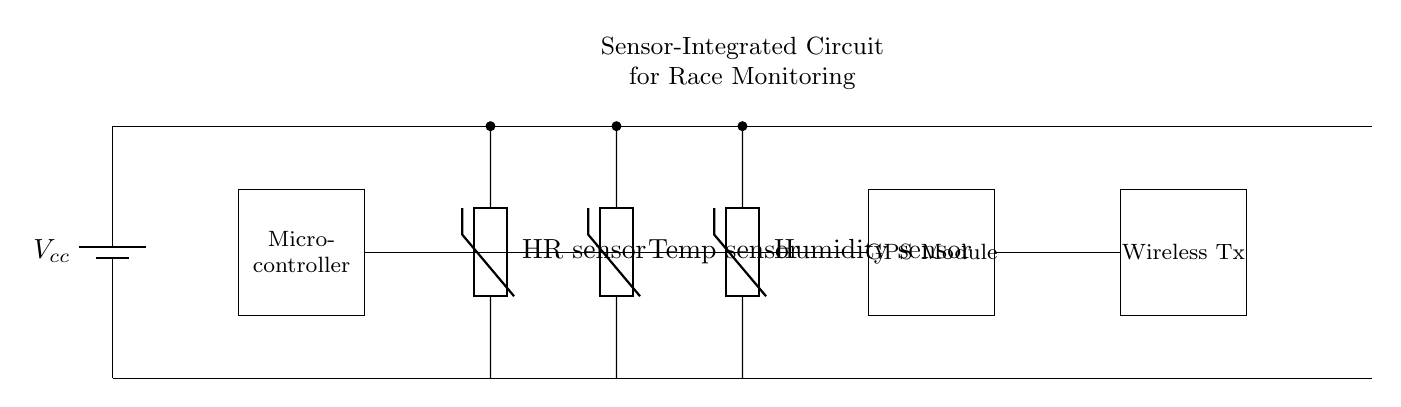What is the main power source in the circuit? The power source is a battery that provides voltage to the circuit. It is shown in the circuit as a battery symbol marked Vcc.
Answer: Battery How many sensors are in the circuit? The circuit contains three sensors: a heart rate sensor, a temperature sensor, and a humidity sensor. Each sensor is represented by a thermistor symbol.
Answer: Three What does the microcontroller connect to? The microcontroller connects to the heart rate sensor, temperature sensor, humidity sensor, and the GPS module. These connections allow it to gather data from these components.
Answer: Four devices What type of module is present at the end of the circuit? The end of the circuit features a wireless transmitter module which indicates the functionality of data transmission.
Answer: Wireless transmitter Which sensors are directly connected to the microcontroller? The sensors directly connected to the microcontroller are the heart rate sensor, temperature sensor, and humidity sensor. This connection facilitates data processing and monitoring.
Answer: Three sensors What is the main function of the GPS module in this circuit? The GPS module is used to track the geographic location of participants during the race, providing crucial location data for monitoring purposes.
Answer: Location tracking How does this circuit contribute to participant safety? The circuit collects health data (like heart rate, temperature, and humidity) that can be monitored in real-time, helping to ensure participant safety by identifying potential health risks during the event.
Answer: Health monitoring 